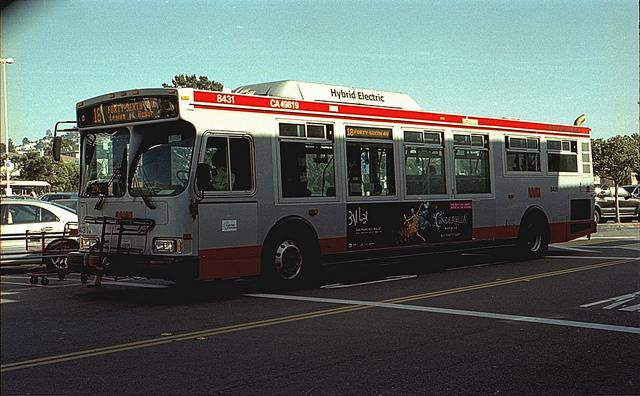How many wheels are visible on the large vehicle?

Choices:
A) two
B) three
C) six
D) four two 